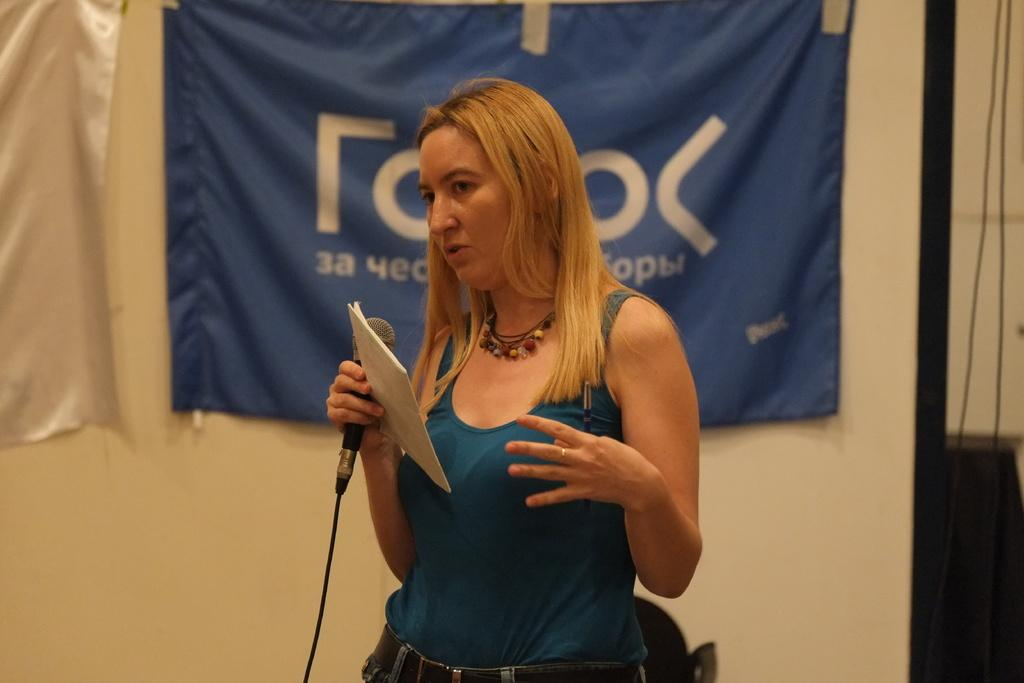What is the main subject of the image? There is a person in the image. What is the person doing in the image? The person is standing and holding a book, a microphone, and a pen in their hands. What can be seen in the background of the image? There are flags visible in the background of the image. How does the person ride the bike in the image? There is no bike present in the image; the person is standing and holding a book, a microphone, and a pen. 